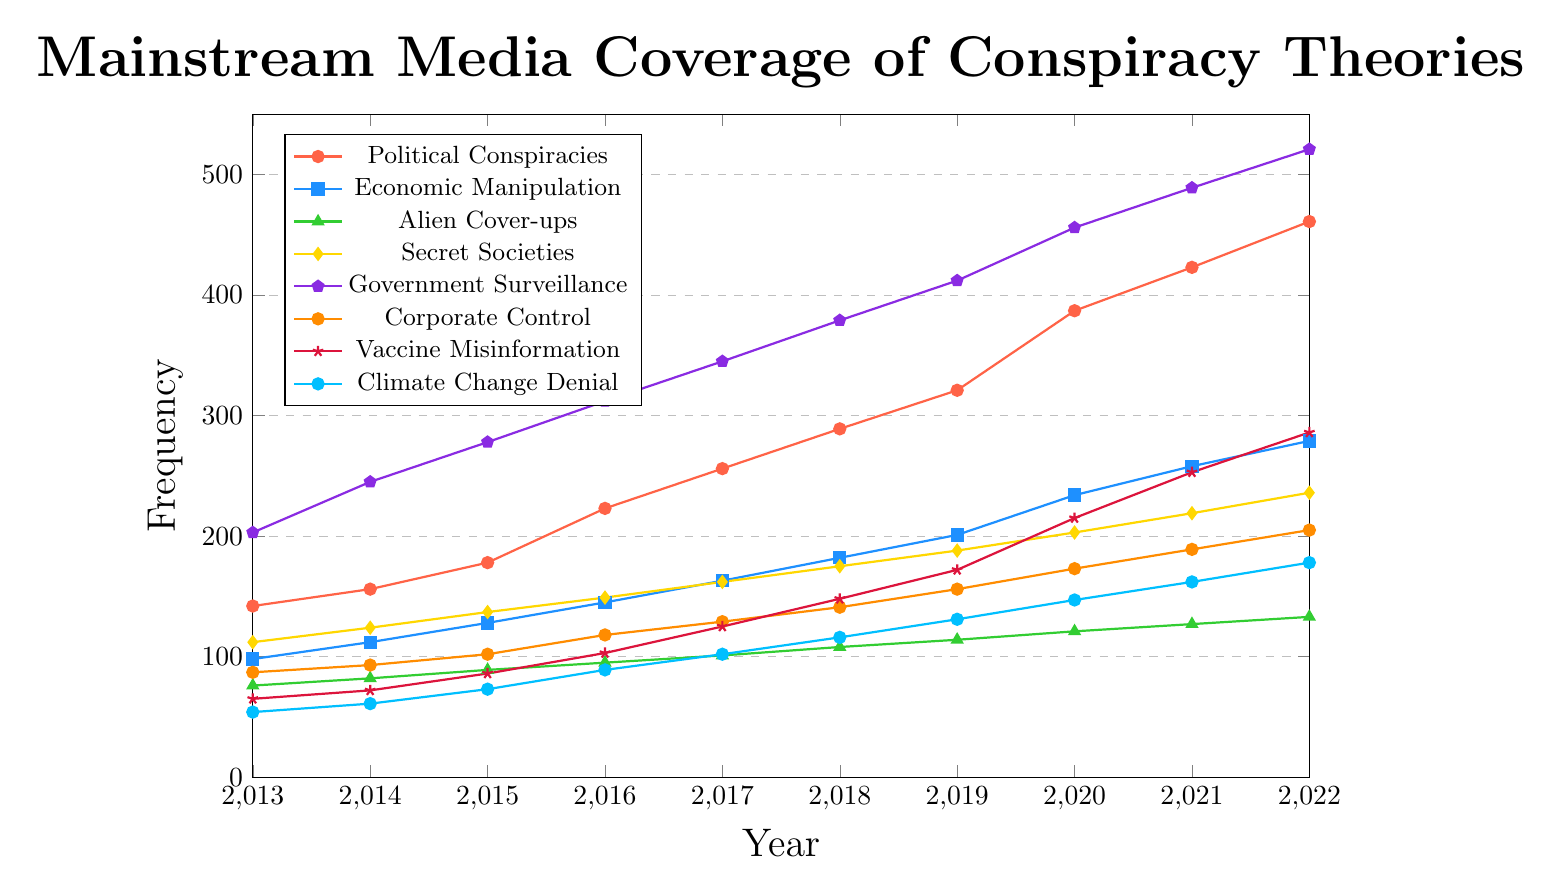What is the total frequency of coverage for Government Surveillance in 2020 and 2022 combined? The figure shows the frequency of Government Surveillance coverage in 2020 as 456 and in 2022 as 521. Adding these two values gives 456 + 521 = 977.
Answer: 977 Between Economic Manipulation and Secret Societies, which topic had a higher frequency in 2018 and by how much? From the figure, Economic Manipulation in 2018 is 182 and Secret Societies in 2018 is 175. The difference is 182 - 175 = 7. Economic Manipulation is higher by 7.
Answer: Economic Manipulation by 7 Which conspiracy topic consistently had the lowest coverage from 2013 to 2022? Reviewing the figure for all years, Alien Cover-ups had the lowest coverage each year, starting from 76 in 2013 to 133 in 2022.
Answer: Alien Cover-ups What was the average annual growth in frequency of coverage for Climate Change Denial from 2013 to 2022? The figure shows Climate Change Denial frequencies as follows: 54 in 2013 and 178 in 2022. The growth over 9 years is 178 - 54 = 124. To find the average annual growth, divide by the number of years, 124 / 9 ≈ 13.78.
Answer: ≈ 13.78 How does the frequency of Corporate Control in 2021 compare to that in 2015? The figure shows Corporate Control frequencies as 189 in 2021 and 102 in 2015. The difference is 189 - 102 = 87, so the 2021 frequency is higher by 87.
Answer: 87 What is the color used for the line representing Vaccine Misinformation? The Vaccine Misinformation line is marked with stars and appears in dark red.
Answer: dark red Which topic had the sharpest increase in coverage from 2019 to 2020? By visual inspection of the figure, Government Surveillance went from 412 in 2019 to 456 in 2020, an increase of 44. This is the largest increase among all topics for the specified years.
Answer: Government Surveillance What's the difference in coverage frequency between Secret Societies and Corporate Control in 2016? According to the figure, Secret Societies are at 149 and Corporate Control at 118 in 2016. The difference is 149 - 118 = 31.
Answer: 31 